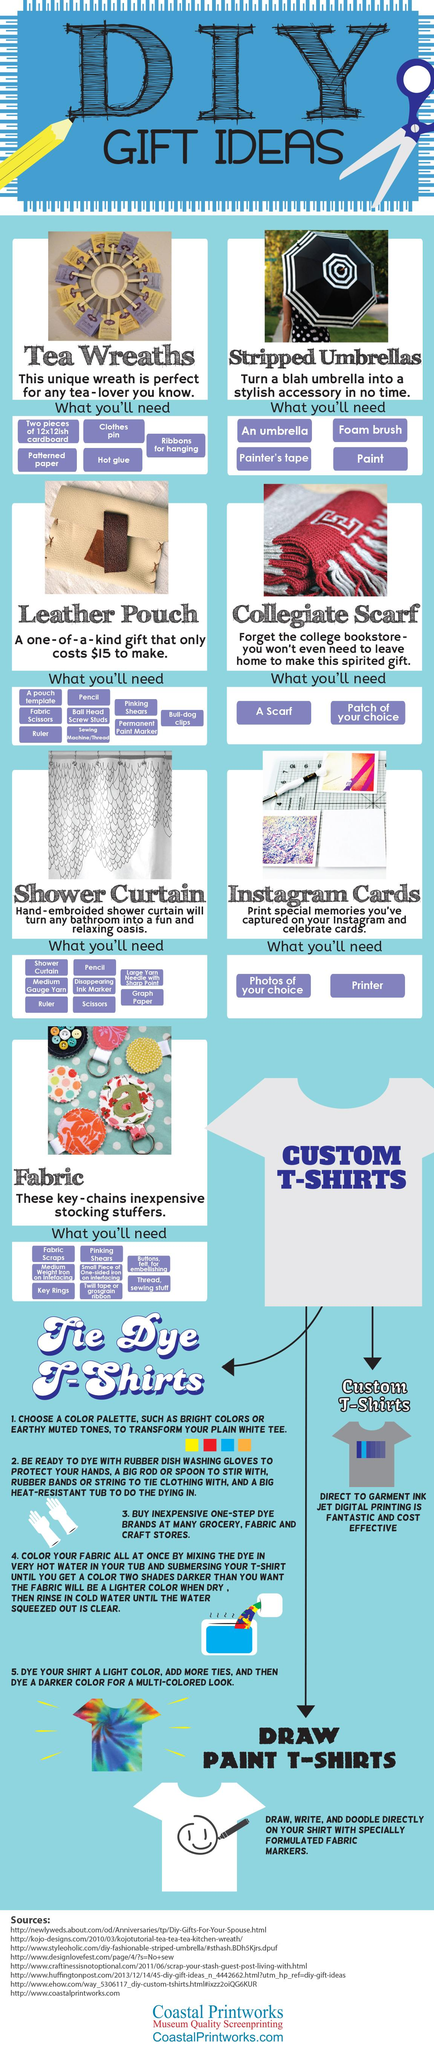Specify some key components in this picture. There is a t-shirt that has a smiley drawn on it, and it is a paint t-shirt. I have a gift idea for you, a leather pouch, and I am giving you the rate for it. The gift idea that requires a printer is Instagram cards. The gift idea in the picture that has a color combination of white and black is the striped umbrellas. There have been three types of t-shirts mentioned. 